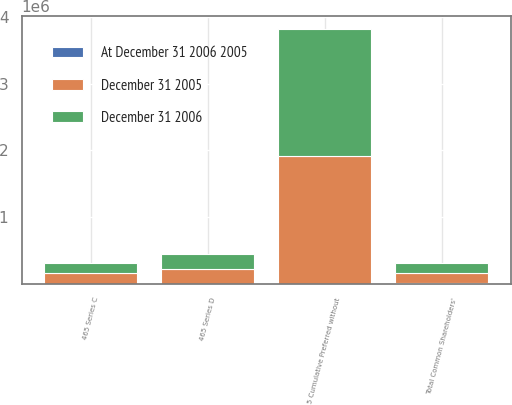Convert chart. <chart><loc_0><loc_0><loc_500><loc_500><stacked_bar_chart><ecel><fcel>Total Common Shareholders'<fcel>5 Cumulative Preferred without<fcel>465 Series C<fcel>465 Series D<nl><fcel>December 31 2005<fcel>153296<fcel>1.91532e+06<fcel>153296<fcel>222330<nl><fcel>December 31 2006<fcel>153296<fcel>1.91532e+06<fcel>153296<fcel>222330<nl><fcel>At December 31 2006 2005<fcel>8087<fcel>175<fcel>16<fcel>22<nl></chart> 